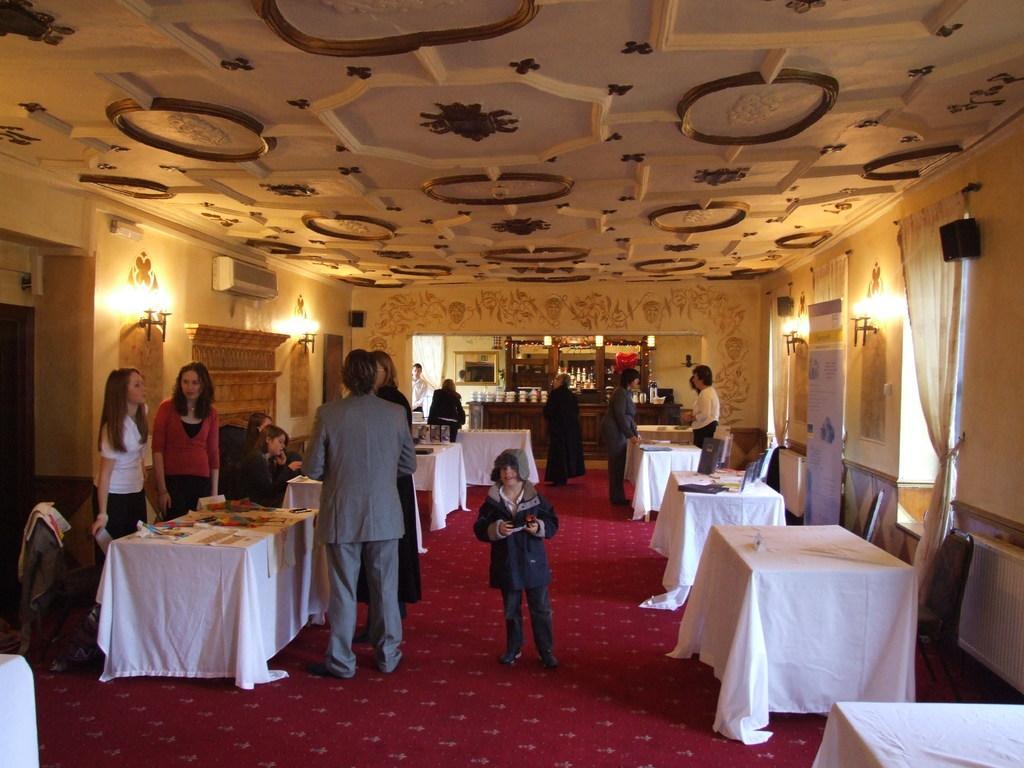Can you describe this image briefly? This Picture describe about the inner view of the hall in which three woman and a man is standing and discussing something. In the middle a boy wearing blue jacket holding the mobile in his hand. On the both the corner right and left side we can see the table with white clothes on it, On the right side we can see the roller banner and alight on the wall, Left side we can see the split ac and some hanging light and a beautiful flower design ceiling top. 